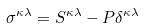Convert formula to latex. <formula><loc_0><loc_0><loc_500><loc_500>\sigma ^ { \kappa \lambda } = S ^ { \kappa \lambda } - P \delta ^ { \kappa \lambda }</formula> 